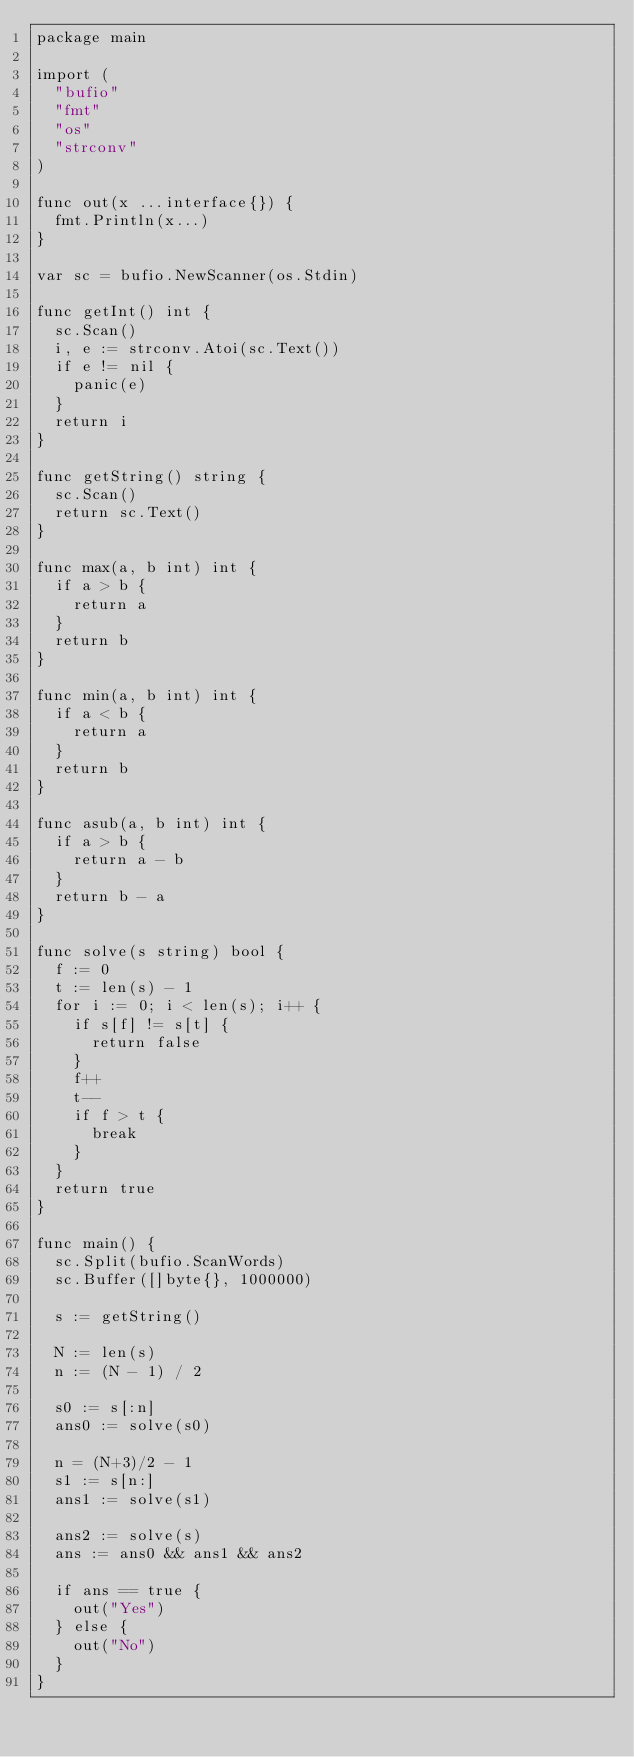Convert code to text. <code><loc_0><loc_0><loc_500><loc_500><_Go_>package main

import (
	"bufio"
	"fmt"
	"os"
	"strconv"
)

func out(x ...interface{}) {
	fmt.Println(x...)
}

var sc = bufio.NewScanner(os.Stdin)

func getInt() int {
	sc.Scan()
	i, e := strconv.Atoi(sc.Text())
	if e != nil {
		panic(e)
	}
	return i
}

func getString() string {
	sc.Scan()
	return sc.Text()
}

func max(a, b int) int {
	if a > b {
		return a
	}
	return b
}

func min(a, b int) int {
	if a < b {
		return a
	}
	return b
}

func asub(a, b int) int {
	if a > b {
		return a - b
	}
	return b - a
}

func solve(s string) bool {
	f := 0
	t := len(s) - 1
	for i := 0; i < len(s); i++ {
		if s[f] != s[t] {
			return false
		}
		f++
		t--
		if f > t {
			break
		}
	}
	return true
}

func main() {
	sc.Split(bufio.ScanWords)
	sc.Buffer([]byte{}, 1000000)

	s := getString()

	N := len(s)
	n := (N - 1) / 2

	s0 := s[:n]
	ans0 := solve(s0)

	n = (N+3)/2 - 1
	s1 := s[n:]
	ans1 := solve(s1)

	ans2 := solve(s)
	ans := ans0 && ans1 && ans2

	if ans == true {
		out("Yes")
	} else {
		out("No")
	}
}
</code> 